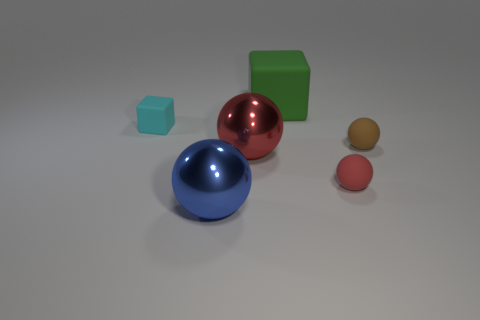Subtract all big red balls. How many balls are left? 3 Subtract 2 balls. How many balls are left? 2 Add 1 small matte spheres. How many objects exist? 7 Subtract all green spheres. Subtract all cyan blocks. How many spheres are left? 4 Subtract all cubes. How many objects are left? 4 Add 4 tiny cyan matte cubes. How many tiny cyan matte cubes are left? 5 Add 3 big blue things. How many big blue things exist? 4 Subtract 0 cyan balls. How many objects are left? 6 Subtract all small cyan blocks. Subtract all large green matte blocks. How many objects are left? 4 